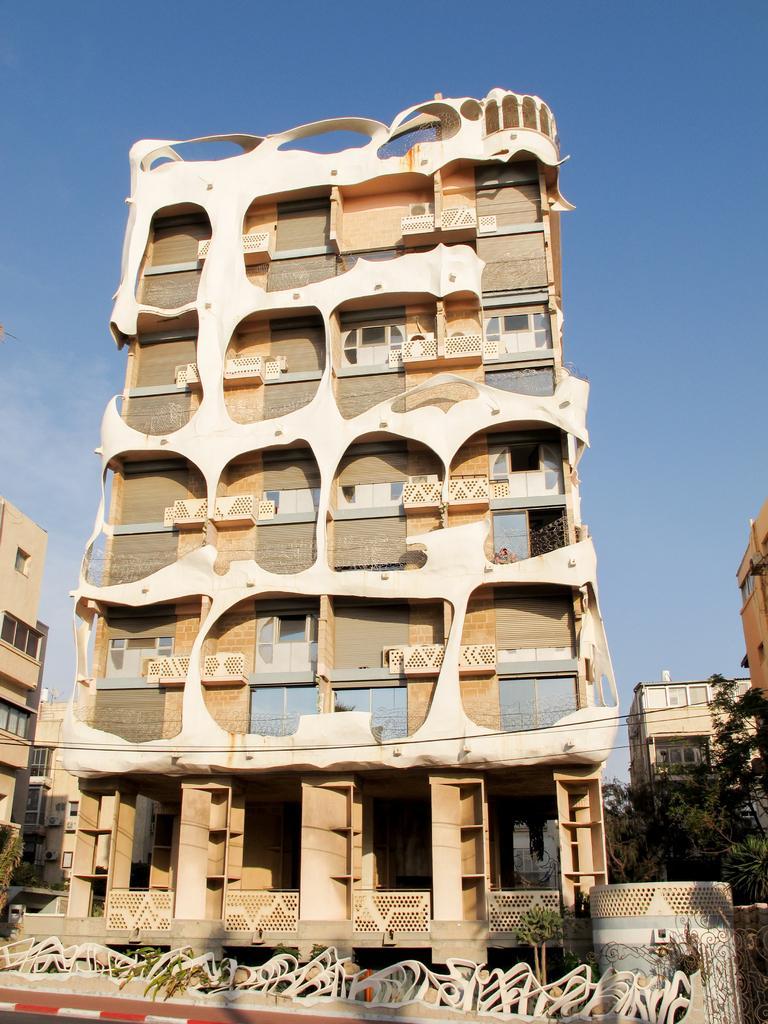How would you summarize this image in a sentence or two? In this image I can see few buildings, few trees, few wires and few plants. In the background I can see clouds and the sky. 